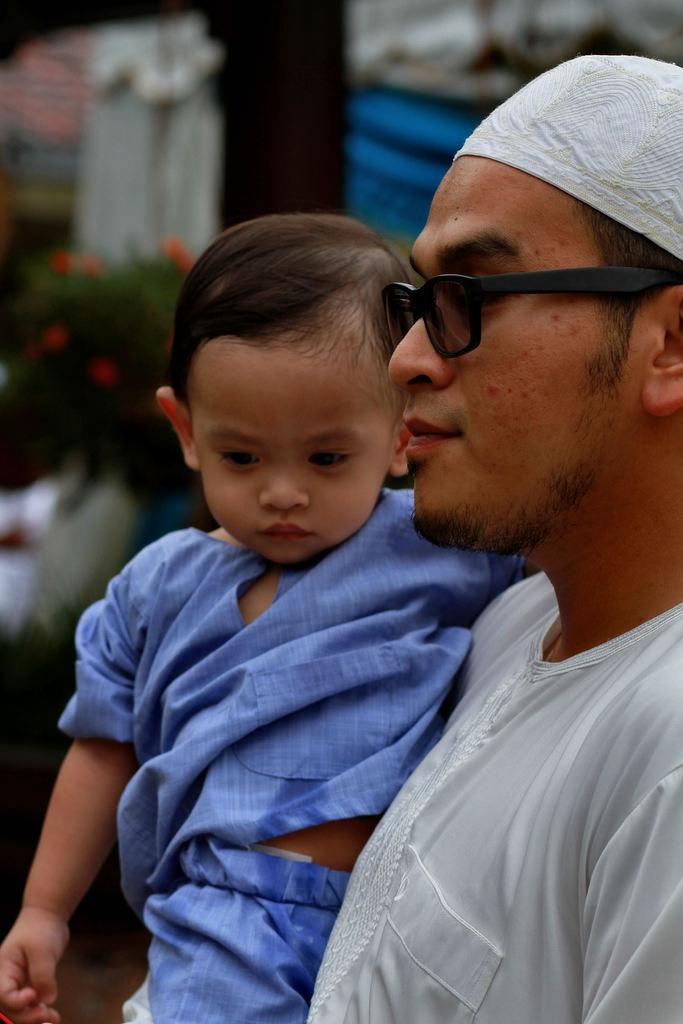Who is the main subject in the image? There is a man in the image. What is the man wearing? The man is wearing glasses. What is the man doing in the image? The man is holding a boy. What can be seen in the background of the image? There is a plant in the background of the image. Can you describe the clarity of the image? Some parts of the image are not clear. What type of art can be seen in the clouds in the image? There are no clouds present in the image, so it is not possible to see any art in them. 